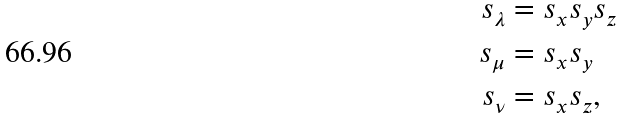<formula> <loc_0><loc_0><loc_500><loc_500>s _ { \lambda } & = s _ { x } s _ { y } s _ { z } \\ s _ { \mu } & = s _ { x } s _ { y } \\ s _ { \nu } & = s _ { x } s _ { z } ,</formula> 